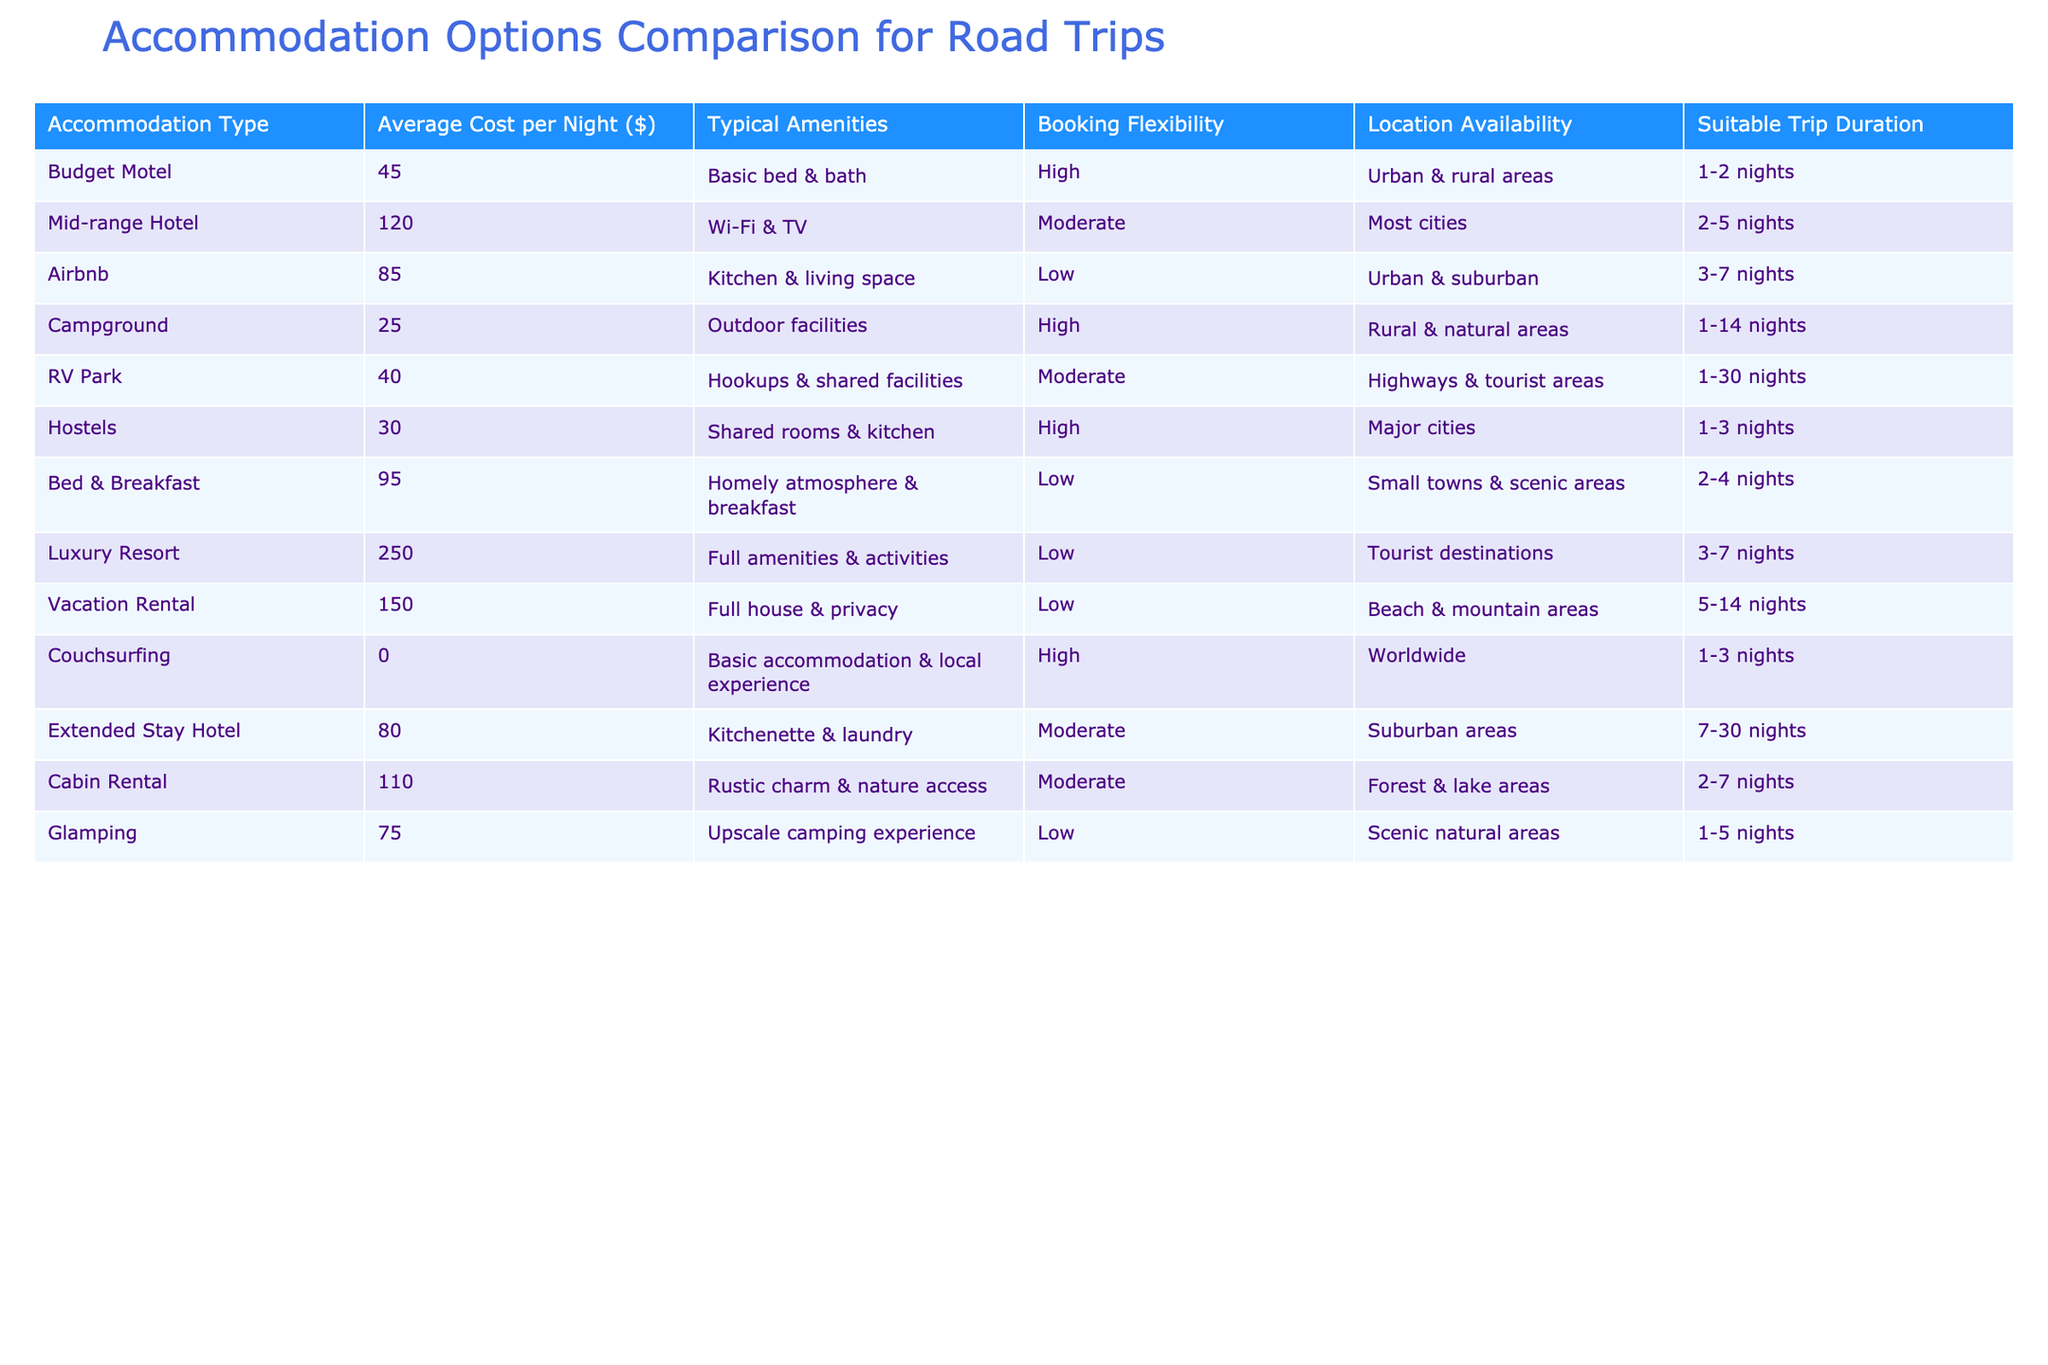What is the average cost per night for a luxury resort? The table shows the average cost per night for a luxury resort listed under the "Average Cost per Night ($)" column, which is 250.
Answer: 250 Which accommodation types have high booking flexibility? By scanning the "Booking Flexibility" column, we can see that Budget Motel, Campground, Hostels, and Couchsurfing are marked as having high flexibility.
Answer: Budget Motel, Campground, Hostels, Couchsurfing Is the average cost of an Airbnb higher than that of a campground? Comparing the "Average Cost per Night ($)" for Airbnb, which is 85, and the campground, which is 25, we can conclude that 85 is greater than 25.
Answer: Yes If a traveler stays at a mid-range hotel for 4 nights, how much will they spend on accommodation? The average cost per night for a mid-range hotel is 120. For 4 nights, the total cost would be 120 * 4 = 480.
Answer: 480 How many accommodation options are suitable for a trip duration of 1 to 3 nights? Checking the "Suitable Trip Duration" column, the options that fall within 1 to 3 nights are Budget Motel, Hostels, and Couchsurfing, totaling 3 options.
Answer: 3 What is the difference between the average cost per night of a vacation rental and a luxury resort? The average for a vacation rental is 150, and for a luxury resort, it is 250. The difference can be calculated as 250 - 150 = 100.
Answer: 100 Do all accommodations listed have at least some amenities? Looking through the "Typical Amenities" column, each accommodation option has listed amenities. Thus, it confirms that they all have at least some type of amenities.
Answer: Yes Which accommodation type has the lowest average cost per night, and what is that cost? Scanning the "Average Cost per Night ($)" column reveals that Campground has the lowest cost at 25.
Answer: Campground, 25 If a traveler has a budget of 100 per night, which accommodation types can they book? Filter the table for accommodation types with an average cost per night of 100 or less. This includes Budget Motel, Campground, RV Park, Hostels, and Couchsurfing.
Answer: Budget Motel, Campground, RV Park, Hostels, Couchsurfing 